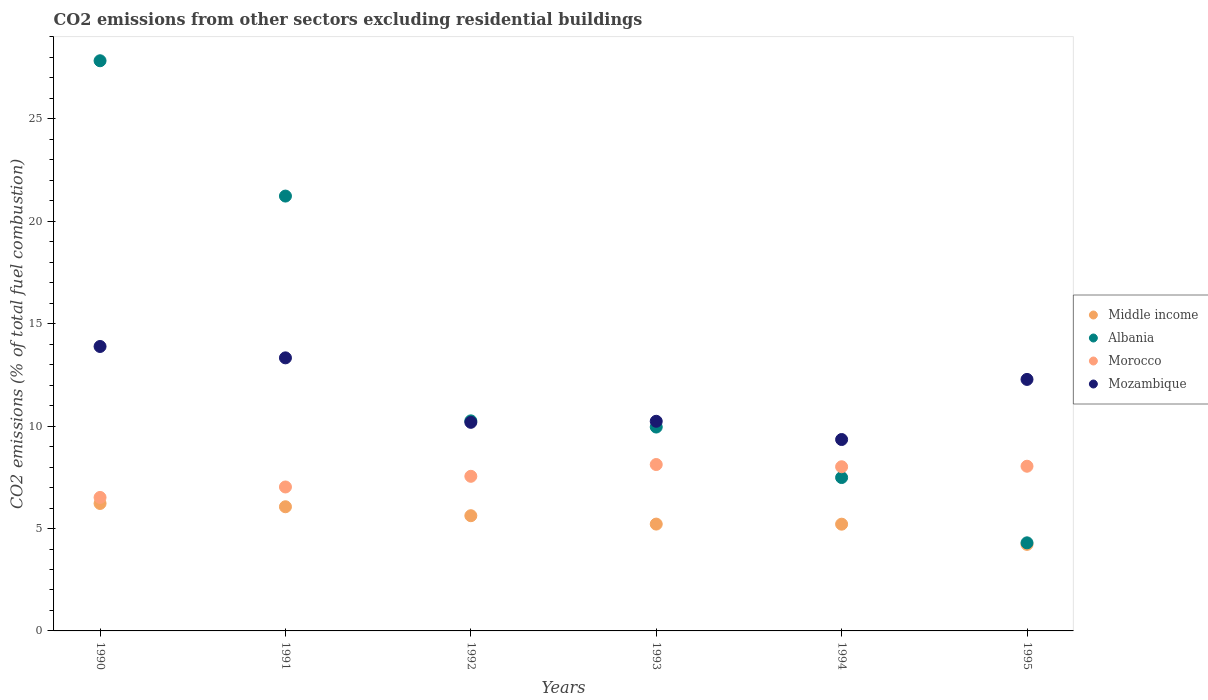How many different coloured dotlines are there?
Ensure brevity in your answer.  4. What is the total CO2 emitted in Morocco in 1990?
Offer a very short reply. 6.52. Across all years, what is the maximum total CO2 emitted in Albania?
Make the answer very short. 27.84. Across all years, what is the minimum total CO2 emitted in Mozambique?
Offer a terse response. 9.35. In which year was the total CO2 emitted in Mozambique minimum?
Provide a short and direct response. 1994. What is the total total CO2 emitted in Middle income in the graph?
Ensure brevity in your answer.  32.56. What is the difference between the total CO2 emitted in Mozambique in 1992 and that in 1995?
Provide a short and direct response. -2.1. What is the difference between the total CO2 emitted in Morocco in 1993 and the total CO2 emitted in Middle income in 1992?
Provide a short and direct response. 2.5. What is the average total CO2 emitted in Albania per year?
Offer a very short reply. 13.51. In the year 1992, what is the difference between the total CO2 emitted in Morocco and total CO2 emitted in Albania?
Provide a short and direct response. -2.71. What is the ratio of the total CO2 emitted in Middle income in 1994 to that in 1995?
Offer a very short reply. 1.23. What is the difference between the highest and the second highest total CO2 emitted in Morocco?
Offer a very short reply. 0.08. What is the difference between the highest and the lowest total CO2 emitted in Middle income?
Provide a succinct answer. 2. Is it the case that in every year, the sum of the total CO2 emitted in Albania and total CO2 emitted in Middle income  is greater than the sum of total CO2 emitted in Morocco and total CO2 emitted in Mozambique?
Keep it short and to the point. No. Is the total CO2 emitted in Albania strictly greater than the total CO2 emitted in Middle income over the years?
Offer a very short reply. Yes. How many dotlines are there?
Offer a very short reply. 4. What is the difference between two consecutive major ticks on the Y-axis?
Offer a very short reply. 5. Are the values on the major ticks of Y-axis written in scientific E-notation?
Your answer should be very brief. No. Does the graph contain any zero values?
Offer a terse response. No. Does the graph contain grids?
Provide a succinct answer. No. How many legend labels are there?
Provide a succinct answer. 4. What is the title of the graph?
Provide a succinct answer. CO2 emissions from other sectors excluding residential buildings. What is the label or title of the X-axis?
Offer a very short reply. Years. What is the label or title of the Y-axis?
Your response must be concise. CO2 emissions (% of total fuel combustion). What is the CO2 emissions (% of total fuel combustion) of Middle income in 1990?
Offer a very short reply. 6.22. What is the CO2 emissions (% of total fuel combustion) in Albania in 1990?
Offer a terse response. 27.84. What is the CO2 emissions (% of total fuel combustion) in Morocco in 1990?
Make the answer very short. 6.52. What is the CO2 emissions (% of total fuel combustion) of Mozambique in 1990?
Provide a short and direct response. 13.89. What is the CO2 emissions (% of total fuel combustion) in Middle income in 1991?
Provide a succinct answer. 6.06. What is the CO2 emissions (% of total fuel combustion) in Albania in 1991?
Provide a succinct answer. 21.23. What is the CO2 emissions (% of total fuel combustion) in Morocco in 1991?
Offer a terse response. 7.03. What is the CO2 emissions (% of total fuel combustion) in Mozambique in 1991?
Make the answer very short. 13.33. What is the CO2 emissions (% of total fuel combustion) of Middle income in 1992?
Provide a succinct answer. 5.63. What is the CO2 emissions (% of total fuel combustion) in Albania in 1992?
Offer a very short reply. 10.26. What is the CO2 emissions (% of total fuel combustion) of Morocco in 1992?
Your answer should be compact. 7.55. What is the CO2 emissions (% of total fuel combustion) of Mozambique in 1992?
Keep it short and to the point. 10.19. What is the CO2 emissions (% of total fuel combustion) of Middle income in 1993?
Offer a terse response. 5.22. What is the CO2 emissions (% of total fuel combustion) of Albania in 1993?
Give a very brief answer. 9.95. What is the CO2 emissions (% of total fuel combustion) of Morocco in 1993?
Keep it short and to the point. 8.12. What is the CO2 emissions (% of total fuel combustion) in Mozambique in 1993?
Your response must be concise. 10.24. What is the CO2 emissions (% of total fuel combustion) of Middle income in 1994?
Ensure brevity in your answer.  5.21. What is the CO2 emissions (% of total fuel combustion) of Albania in 1994?
Your response must be concise. 7.49. What is the CO2 emissions (% of total fuel combustion) of Morocco in 1994?
Make the answer very short. 8.02. What is the CO2 emissions (% of total fuel combustion) of Mozambique in 1994?
Make the answer very short. 9.35. What is the CO2 emissions (% of total fuel combustion) of Middle income in 1995?
Your response must be concise. 4.23. What is the CO2 emissions (% of total fuel combustion) in Albania in 1995?
Make the answer very short. 4.3. What is the CO2 emissions (% of total fuel combustion) in Morocco in 1995?
Give a very brief answer. 8.04. What is the CO2 emissions (% of total fuel combustion) of Mozambique in 1995?
Your answer should be very brief. 12.28. Across all years, what is the maximum CO2 emissions (% of total fuel combustion) of Middle income?
Offer a terse response. 6.22. Across all years, what is the maximum CO2 emissions (% of total fuel combustion) of Albania?
Ensure brevity in your answer.  27.84. Across all years, what is the maximum CO2 emissions (% of total fuel combustion) of Morocco?
Offer a very short reply. 8.12. Across all years, what is the maximum CO2 emissions (% of total fuel combustion) in Mozambique?
Keep it short and to the point. 13.89. Across all years, what is the minimum CO2 emissions (% of total fuel combustion) in Middle income?
Ensure brevity in your answer.  4.23. Across all years, what is the minimum CO2 emissions (% of total fuel combustion) of Albania?
Ensure brevity in your answer.  4.3. Across all years, what is the minimum CO2 emissions (% of total fuel combustion) in Morocco?
Provide a succinct answer. 6.52. Across all years, what is the minimum CO2 emissions (% of total fuel combustion) of Mozambique?
Offer a terse response. 9.35. What is the total CO2 emissions (% of total fuel combustion) in Middle income in the graph?
Provide a short and direct response. 32.56. What is the total CO2 emissions (% of total fuel combustion) of Albania in the graph?
Give a very brief answer. 81.07. What is the total CO2 emissions (% of total fuel combustion) in Morocco in the graph?
Offer a very short reply. 45.28. What is the total CO2 emissions (% of total fuel combustion) in Mozambique in the graph?
Make the answer very short. 69.27. What is the difference between the CO2 emissions (% of total fuel combustion) of Middle income in 1990 and that in 1991?
Your response must be concise. 0.16. What is the difference between the CO2 emissions (% of total fuel combustion) of Albania in 1990 and that in 1991?
Your answer should be compact. 6.61. What is the difference between the CO2 emissions (% of total fuel combustion) in Morocco in 1990 and that in 1991?
Your response must be concise. -0.51. What is the difference between the CO2 emissions (% of total fuel combustion) of Mozambique in 1990 and that in 1991?
Keep it short and to the point. 0.56. What is the difference between the CO2 emissions (% of total fuel combustion) of Middle income in 1990 and that in 1992?
Provide a short and direct response. 0.6. What is the difference between the CO2 emissions (% of total fuel combustion) of Albania in 1990 and that in 1992?
Ensure brevity in your answer.  17.58. What is the difference between the CO2 emissions (% of total fuel combustion) in Morocco in 1990 and that in 1992?
Provide a succinct answer. -1.03. What is the difference between the CO2 emissions (% of total fuel combustion) of Mozambique in 1990 and that in 1992?
Provide a succinct answer. 3.7. What is the difference between the CO2 emissions (% of total fuel combustion) in Middle income in 1990 and that in 1993?
Make the answer very short. 1.01. What is the difference between the CO2 emissions (% of total fuel combustion) in Albania in 1990 and that in 1993?
Offer a very short reply. 17.89. What is the difference between the CO2 emissions (% of total fuel combustion) of Morocco in 1990 and that in 1993?
Offer a terse response. -1.61. What is the difference between the CO2 emissions (% of total fuel combustion) of Mozambique in 1990 and that in 1993?
Your answer should be very brief. 3.65. What is the difference between the CO2 emissions (% of total fuel combustion) of Albania in 1990 and that in 1994?
Make the answer very short. 20.35. What is the difference between the CO2 emissions (% of total fuel combustion) of Morocco in 1990 and that in 1994?
Your answer should be compact. -1.5. What is the difference between the CO2 emissions (% of total fuel combustion) in Mozambique in 1990 and that in 1994?
Make the answer very short. 4.54. What is the difference between the CO2 emissions (% of total fuel combustion) of Middle income in 1990 and that in 1995?
Your answer should be very brief. 2. What is the difference between the CO2 emissions (% of total fuel combustion) of Albania in 1990 and that in 1995?
Offer a very short reply. 23.54. What is the difference between the CO2 emissions (% of total fuel combustion) in Morocco in 1990 and that in 1995?
Offer a very short reply. -1.52. What is the difference between the CO2 emissions (% of total fuel combustion) of Mozambique in 1990 and that in 1995?
Give a very brief answer. 1.61. What is the difference between the CO2 emissions (% of total fuel combustion) in Middle income in 1991 and that in 1992?
Give a very brief answer. 0.44. What is the difference between the CO2 emissions (% of total fuel combustion) of Albania in 1991 and that in 1992?
Provide a succinct answer. 10.98. What is the difference between the CO2 emissions (% of total fuel combustion) of Morocco in 1991 and that in 1992?
Give a very brief answer. -0.52. What is the difference between the CO2 emissions (% of total fuel combustion) of Mozambique in 1991 and that in 1992?
Make the answer very short. 3.15. What is the difference between the CO2 emissions (% of total fuel combustion) in Middle income in 1991 and that in 1993?
Provide a succinct answer. 0.85. What is the difference between the CO2 emissions (% of total fuel combustion) of Albania in 1991 and that in 1993?
Your response must be concise. 11.28. What is the difference between the CO2 emissions (% of total fuel combustion) of Morocco in 1991 and that in 1993?
Make the answer very short. -1.1. What is the difference between the CO2 emissions (% of total fuel combustion) of Mozambique in 1991 and that in 1993?
Give a very brief answer. 3.1. What is the difference between the CO2 emissions (% of total fuel combustion) in Middle income in 1991 and that in 1994?
Your response must be concise. 0.85. What is the difference between the CO2 emissions (% of total fuel combustion) in Albania in 1991 and that in 1994?
Offer a terse response. 13.74. What is the difference between the CO2 emissions (% of total fuel combustion) in Morocco in 1991 and that in 1994?
Your response must be concise. -0.99. What is the difference between the CO2 emissions (% of total fuel combustion) of Mozambique in 1991 and that in 1994?
Ensure brevity in your answer.  3.99. What is the difference between the CO2 emissions (% of total fuel combustion) of Middle income in 1991 and that in 1995?
Your response must be concise. 1.84. What is the difference between the CO2 emissions (% of total fuel combustion) in Albania in 1991 and that in 1995?
Offer a very short reply. 16.93. What is the difference between the CO2 emissions (% of total fuel combustion) of Morocco in 1991 and that in 1995?
Your response must be concise. -1.01. What is the difference between the CO2 emissions (% of total fuel combustion) of Mozambique in 1991 and that in 1995?
Keep it short and to the point. 1.05. What is the difference between the CO2 emissions (% of total fuel combustion) of Middle income in 1992 and that in 1993?
Make the answer very short. 0.41. What is the difference between the CO2 emissions (% of total fuel combustion) in Albania in 1992 and that in 1993?
Make the answer very short. 0.3. What is the difference between the CO2 emissions (% of total fuel combustion) of Morocco in 1992 and that in 1993?
Make the answer very short. -0.57. What is the difference between the CO2 emissions (% of total fuel combustion) in Mozambique in 1992 and that in 1993?
Make the answer very short. -0.05. What is the difference between the CO2 emissions (% of total fuel combustion) in Middle income in 1992 and that in 1994?
Provide a succinct answer. 0.41. What is the difference between the CO2 emissions (% of total fuel combustion) in Albania in 1992 and that in 1994?
Keep it short and to the point. 2.77. What is the difference between the CO2 emissions (% of total fuel combustion) in Morocco in 1992 and that in 1994?
Provide a short and direct response. -0.47. What is the difference between the CO2 emissions (% of total fuel combustion) of Mozambique in 1992 and that in 1994?
Ensure brevity in your answer.  0.84. What is the difference between the CO2 emissions (% of total fuel combustion) of Middle income in 1992 and that in 1995?
Offer a very short reply. 1.4. What is the difference between the CO2 emissions (% of total fuel combustion) in Albania in 1992 and that in 1995?
Give a very brief answer. 5.96. What is the difference between the CO2 emissions (% of total fuel combustion) of Morocco in 1992 and that in 1995?
Keep it short and to the point. -0.49. What is the difference between the CO2 emissions (% of total fuel combustion) of Mozambique in 1992 and that in 1995?
Keep it short and to the point. -2.1. What is the difference between the CO2 emissions (% of total fuel combustion) of Middle income in 1993 and that in 1994?
Offer a very short reply. 0. What is the difference between the CO2 emissions (% of total fuel combustion) of Albania in 1993 and that in 1994?
Make the answer very short. 2.47. What is the difference between the CO2 emissions (% of total fuel combustion) of Morocco in 1993 and that in 1994?
Your answer should be compact. 0.11. What is the difference between the CO2 emissions (% of total fuel combustion) in Mozambique in 1993 and that in 1994?
Keep it short and to the point. 0.89. What is the difference between the CO2 emissions (% of total fuel combustion) in Middle income in 1993 and that in 1995?
Give a very brief answer. 0.99. What is the difference between the CO2 emissions (% of total fuel combustion) of Albania in 1993 and that in 1995?
Your answer should be compact. 5.65. What is the difference between the CO2 emissions (% of total fuel combustion) of Morocco in 1993 and that in 1995?
Your answer should be compact. 0.08. What is the difference between the CO2 emissions (% of total fuel combustion) of Mozambique in 1993 and that in 1995?
Offer a terse response. -2.04. What is the difference between the CO2 emissions (% of total fuel combustion) in Middle income in 1994 and that in 1995?
Provide a succinct answer. 0.99. What is the difference between the CO2 emissions (% of total fuel combustion) in Albania in 1994 and that in 1995?
Keep it short and to the point. 3.19. What is the difference between the CO2 emissions (% of total fuel combustion) in Morocco in 1994 and that in 1995?
Give a very brief answer. -0.03. What is the difference between the CO2 emissions (% of total fuel combustion) in Mozambique in 1994 and that in 1995?
Your answer should be very brief. -2.93. What is the difference between the CO2 emissions (% of total fuel combustion) of Middle income in 1990 and the CO2 emissions (% of total fuel combustion) of Albania in 1991?
Keep it short and to the point. -15.01. What is the difference between the CO2 emissions (% of total fuel combustion) of Middle income in 1990 and the CO2 emissions (% of total fuel combustion) of Morocco in 1991?
Offer a very short reply. -0.81. What is the difference between the CO2 emissions (% of total fuel combustion) in Middle income in 1990 and the CO2 emissions (% of total fuel combustion) in Mozambique in 1991?
Your answer should be compact. -7.11. What is the difference between the CO2 emissions (% of total fuel combustion) of Albania in 1990 and the CO2 emissions (% of total fuel combustion) of Morocco in 1991?
Your answer should be compact. 20.81. What is the difference between the CO2 emissions (% of total fuel combustion) of Albania in 1990 and the CO2 emissions (% of total fuel combustion) of Mozambique in 1991?
Your answer should be compact. 14.51. What is the difference between the CO2 emissions (% of total fuel combustion) in Morocco in 1990 and the CO2 emissions (% of total fuel combustion) in Mozambique in 1991?
Provide a short and direct response. -6.82. What is the difference between the CO2 emissions (% of total fuel combustion) in Middle income in 1990 and the CO2 emissions (% of total fuel combustion) in Albania in 1992?
Ensure brevity in your answer.  -4.03. What is the difference between the CO2 emissions (% of total fuel combustion) of Middle income in 1990 and the CO2 emissions (% of total fuel combustion) of Morocco in 1992?
Make the answer very short. -1.33. What is the difference between the CO2 emissions (% of total fuel combustion) in Middle income in 1990 and the CO2 emissions (% of total fuel combustion) in Mozambique in 1992?
Your response must be concise. -3.96. What is the difference between the CO2 emissions (% of total fuel combustion) in Albania in 1990 and the CO2 emissions (% of total fuel combustion) in Morocco in 1992?
Make the answer very short. 20.29. What is the difference between the CO2 emissions (% of total fuel combustion) of Albania in 1990 and the CO2 emissions (% of total fuel combustion) of Mozambique in 1992?
Provide a succinct answer. 17.65. What is the difference between the CO2 emissions (% of total fuel combustion) of Morocco in 1990 and the CO2 emissions (% of total fuel combustion) of Mozambique in 1992?
Provide a succinct answer. -3.67. What is the difference between the CO2 emissions (% of total fuel combustion) of Middle income in 1990 and the CO2 emissions (% of total fuel combustion) of Albania in 1993?
Your response must be concise. -3.73. What is the difference between the CO2 emissions (% of total fuel combustion) in Middle income in 1990 and the CO2 emissions (% of total fuel combustion) in Morocco in 1993?
Provide a short and direct response. -1.9. What is the difference between the CO2 emissions (% of total fuel combustion) of Middle income in 1990 and the CO2 emissions (% of total fuel combustion) of Mozambique in 1993?
Offer a very short reply. -4.01. What is the difference between the CO2 emissions (% of total fuel combustion) of Albania in 1990 and the CO2 emissions (% of total fuel combustion) of Morocco in 1993?
Provide a succinct answer. 19.72. What is the difference between the CO2 emissions (% of total fuel combustion) in Albania in 1990 and the CO2 emissions (% of total fuel combustion) in Mozambique in 1993?
Keep it short and to the point. 17.6. What is the difference between the CO2 emissions (% of total fuel combustion) of Morocco in 1990 and the CO2 emissions (% of total fuel combustion) of Mozambique in 1993?
Your answer should be very brief. -3.72. What is the difference between the CO2 emissions (% of total fuel combustion) in Middle income in 1990 and the CO2 emissions (% of total fuel combustion) in Albania in 1994?
Your response must be concise. -1.27. What is the difference between the CO2 emissions (% of total fuel combustion) in Middle income in 1990 and the CO2 emissions (% of total fuel combustion) in Morocco in 1994?
Offer a very short reply. -1.79. What is the difference between the CO2 emissions (% of total fuel combustion) of Middle income in 1990 and the CO2 emissions (% of total fuel combustion) of Mozambique in 1994?
Your response must be concise. -3.12. What is the difference between the CO2 emissions (% of total fuel combustion) in Albania in 1990 and the CO2 emissions (% of total fuel combustion) in Morocco in 1994?
Offer a terse response. 19.82. What is the difference between the CO2 emissions (% of total fuel combustion) in Albania in 1990 and the CO2 emissions (% of total fuel combustion) in Mozambique in 1994?
Offer a very short reply. 18.49. What is the difference between the CO2 emissions (% of total fuel combustion) of Morocco in 1990 and the CO2 emissions (% of total fuel combustion) of Mozambique in 1994?
Your response must be concise. -2.83. What is the difference between the CO2 emissions (% of total fuel combustion) of Middle income in 1990 and the CO2 emissions (% of total fuel combustion) of Albania in 1995?
Keep it short and to the point. 1.92. What is the difference between the CO2 emissions (% of total fuel combustion) of Middle income in 1990 and the CO2 emissions (% of total fuel combustion) of Morocco in 1995?
Provide a succinct answer. -1.82. What is the difference between the CO2 emissions (% of total fuel combustion) of Middle income in 1990 and the CO2 emissions (% of total fuel combustion) of Mozambique in 1995?
Your answer should be very brief. -6.06. What is the difference between the CO2 emissions (% of total fuel combustion) in Albania in 1990 and the CO2 emissions (% of total fuel combustion) in Morocco in 1995?
Ensure brevity in your answer.  19.8. What is the difference between the CO2 emissions (% of total fuel combustion) in Albania in 1990 and the CO2 emissions (% of total fuel combustion) in Mozambique in 1995?
Provide a short and direct response. 15.56. What is the difference between the CO2 emissions (% of total fuel combustion) of Morocco in 1990 and the CO2 emissions (% of total fuel combustion) of Mozambique in 1995?
Offer a terse response. -5.76. What is the difference between the CO2 emissions (% of total fuel combustion) of Middle income in 1991 and the CO2 emissions (% of total fuel combustion) of Albania in 1992?
Your answer should be compact. -4.19. What is the difference between the CO2 emissions (% of total fuel combustion) of Middle income in 1991 and the CO2 emissions (% of total fuel combustion) of Morocco in 1992?
Make the answer very short. -1.49. What is the difference between the CO2 emissions (% of total fuel combustion) in Middle income in 1991 and the CO2 emissions (% of total fuel combustion) in Mozambique in 1992?
Your response must be concise. -4.12. What is the difference between the CO2 emissions (% of total fuel combustion) in Albania in 1991 and the CO2 emissions (% of total fuel combustion) in Morocco in 1992?
Your response must be concise. 13.68. What is the difference between the CO2 emissions (% of total fuel combustion) in Albania in 1991 and the CO2 emissions (% of total fuel combustion) in Mozambique in 1992?
Give a very brief answer. 11.05. What is the difference between the CO2 emissions (% of total fuel combustion) in Morocco in 1991 and the CO2 emissions (% of total fuel combustion) in Mozambique in 1992?
Offer a very short reply. -3.16. What is the difference between the CO2 emissions (% of total fuel combustion) of Middle income in 1991 and the CO2 emissions (% of total fuel combustion) of Albania in 1993?
Offer a terse response. -3.89. What is the difference between the CO2 emissions (% of total fuel combustion) of Middle income in 1991 and the CO2 emissions (% of total fuel combustion) of Morocco in 1993?
Provide a succinct answer. -2.06. What is the difference between the CO2 emissions (% of total fuel combustion) of Middle income in 1991 and the CO2 emissions (% of total fuel combustion) of Mozambique in 1993?
Keep it short and to the point. -4.17. What is the difference between the CO2 emissions (% of total fuel combustion) in Albania in 1991 and the CO2 emissions (% of total fuel combustion) in Morocco in 1993?
Keep it short and to the point. 13.11. What is the difference between the CO2 emissions (% of total fuel combustion) of Albania in 1991 and the CO2 emissions (% of total fuel combustion) of Mozambique in 1993?
Provide a short and direct response. 11. What is the difference between the CO2 emissions (% of total fuel combustion) of Morocco in 1991 and the CO2 emissions (% of total fuel combustion) of Mozambique in 1993?
Ensure brevity in your answer.  -3.21. What is the difference between the CO2 emissions (% of total fuel combustion) in Middle income in 1991 and the CO2 emissions (% of total fuel combustion) in Albania in 1994?
Offer a very short reply. -1.43. What is the difference between the CO2 emissions (% of total fuel combustion) in Middle income in 1991 and the CO2 emissions (% of total fuel combustion) in Morocco in 1994?
Ensure brevity in your answer.  -1.95. What is the difference between the CO2 emissions (% of total fuel combustion) of Middle income in 1991 and the CO2 emissions (% of total fuel combustion) of Mozambique in 1994?
Offer a terse response. -3.28. What is the difference between the CO2 emissions (% of total fuel combustion) of Albania in 1991 and the CO2 emissions (% of total fuel combustion) of Morocco in 1994?
Keep it short and to the point. 13.22. What is the difference between the CO2 emissions (% of total fuel combustion) of Albania in 1991 and the CO2 emissions (% of total fuel combustion) of Mozambique in 1994?
Give a very brief answer. 11.89. What is the difference between the CO2 emissions (% of total fuel combustion) in Morocco in 1991 and the CO2 emissions (% of total fuel combustion) in Mozambique in 1994?
Provide a succinct answer. -2.32. What is the difference between the CO2 emissions (% of total fuel combustion) in Middle income in 1991 and the CO2 emissions (% of total fuel combustion) in Albania in 1995?
Offer a terse response. 1.76. What is the difference between the CO2 emissions (% of total fuel combustion) in Middle income in 1991 and the CO2 emissions (% of total fuel combustion) in Morocco in 1995?
Your answer should be compact. -1.98. What is the difference between the CO2 emissions (% of total fuel combustion) in Middle income in 1991 and the CO2 emissions (% of total fuel combustion) in Mozambique in 1995?
Provide a short and direct response. -6.22. What is the difference between the CO2 emissions (% of total fuel combustion) in Albania in 1991 and the CO2 emissions (% of total fuel combustion) in Morocco in 1995?
Ensure brevity in your answer.  13.19. What is the difference between the CO2 emissions (% of total fuel combustion) of Albania in 1991 and the CO2 emissions (% of total fuel combustion) of Mozambique in 1995?
Give a very brief answer. 8.95. What is the difference between the CO2 emissions (% of total fuel combustion) in Morocco in 1991 and the CO2 emissions (% of total fuel combustion) in Mozambique in 1995?
Make the answer very short. -5.25. What is the difference between the CO2 emissions (% of total fuel combustion) in Middle income in 1992 and the CO2 emissions (% of total fuel combustion) in Albania in 1993?
Offer a terse response. -4.33. What is the difference between the CO2 emissions (% of total fuel combustion) in Middle income in 1992 and the CO2 emissions (% of total fuel combustion) in Morocco in 1993?
Ensure brevity in your answer.  -2.5. What is the difference between the CO2 emissions (% of total fuel combustion) in Middle income in 1992 and the CO2 emissions (% of total fuel combustion) in Mozambique in 1993?
Offer a very short reply. -4.61. What is the difference between the CO2 emissions (% of total fuel combustion) of Albania in 1992 and the CO2 emissions (% of total fuel combustion) of Morocco in 1993?
Give a very brief answer. 2.13. What is the difference between the CO2 emissions (% of total fuel combustion) in Albania in 1992 and the CO2 emissions (% of total fuel combustion) in Mozambique in 1993?
Offer a very short reply. 0.02. What is the difference between the CO2 emissions (% of total fuel combustion) in Morocco in 1992 and the CO2 emissions (% of total fuel combustion) in Mozambique in 1993?
Ensure brevity in your answer.  -2.69. What is the difference between the CO2 emissions (% of total fuel combustion) of Middle income in 1992 and the CO2 emissions (% of total fuel combustion) of Albania in 1994?
Provide a short and direct response. -1.86. What is the difference between the CO2 emissions (% of total fuel combustion) in Middle income in 1992 and the CO2 emissions (% of total fuel combustion) in Morocco in 1994?
Make the answer very short. -2.39. What is the difference between the CO2 emissions (% of total fuel combustion) in Middle income in 1992 and the CO2 emissions (% of total fuel combustion) in Mozambique in 1994?
Your answer should be very brief. -3.72. What is the difference between the CO2 emissions (% of total fuel combustion) of Albania in 1992 and the CO2 emissions (% of total fuel combustion) of Morocco in 1994?
Your answer should be very brief. 2.24. What is the difference between the CO2 emissions (% of total fuel combustion) in Albania in 1992 and the CO2 emissions (% of total fuel combustion) in Mozambique in 1994?
Your answer should be compact. 0.91. What is the difference between the CO2 emissions (% of total fuel combustion) in Morocco in 1992 and the CO2 emissions (% of total fuel combustion) in Mozambique in 1994?
Your answer should be very brief. -1.8. What is the difference between the CO2 emissions (% of total fuel combustion) of Middle income in 1992 and the CO2 emissions (% of total fuel combustion) of Albania in 1995?
Keep it short and to the point. 1.32. What is the difference between the CO2 emissions (% of total fuel combustion) of Middle income in 1992 and the CO2 emissions (% of total fuel combustion) of Morocco in 1995?
Your answer should be compact. -2.42. What is the difference between the CO2 emissions (% of total fuel combustion) of Middle income in 1992 and the CO2 emissions (% of total fuel combustion) of Mozambique in 1995?
Offer a terse response. -6.66. What is the difference between the CO2 emissions (% of total fuel combustion) in Albania in 1992 and the CO2 emissions (% of total fuel combustion) in Morocco in 1995?
Provide a short and direct response. 2.21. What is the difference between the CO2 emissions (% of total fuel combustion) in Albania in 1992 and the CO2 emissions (% of total fuel combustion) in Mozambique in 1995?
Offer a very short reply. -2.02. What is the difference between the CO2 emissions (% of total fuel combustion) of Morocco in 1992 and the CO2 emissions (% of total fuel combustion) of Mozambique in 1995?
Keep it short and to the point. -4.73. What is the difference between the CO2 emissions (% of total fuel combustion) in Middle income in 1993 and the CO2 emissions (% of total fuel combustion) in Albania in 1994?
Make the answer very short. -2.27. What is the difference between the CO2 emissions (% of total fuel combustion) in Middle income in 1993 and the CO2 emissions (% of total fuel combustion) in Morocco in 1994?
Offer a very short reply. -2.8. What is the difference between the CO2 emissions (% of total fuel combustion) of Middle income in 1993 and the CO2 emissions (% of total fuel combustion) of Mozambique in 1994?
Give a very brief answer. -4.13. What is the difference between the CO2 emissions (% of total fuel combustion) in Albania in 1993 and the CO2 emissions (% of total fuel combustion) in Morocco in 1994?
Offer a very short reply. 1.94. What is the difference between the CO2 emissions (% of total fuel combustion) in Albania in 1993 and the CO2 emissions (% of total fuel combustion) in Mozambique in 1994?
Your answer should be very brief. 0.61. What is the difference between the CO2 emissions (% of total fuel combustion) of Morocco in 1993 and the CO2 emissions (% of total fuel combustion) of Mozambique in 1994?
Ensure brevity in your answer.  -1.22. What is the difference between the CO2 emissions (% of total fuel combustion) of Middle income in 1993 and the CO2 emissions (% of total fuel combustion) of Albania in 1995?
Your response must be concise. 0.92. What is the difference between the CO2 emissions (% of total fuel combustion) of Middle income in 1993 and the CO2 emissions (% of total fuel combustion) of Morocco in 1995?
Your answer should be very brief. -2.83. What is the difference between the CO2 emissions (% of total fuel combustion) of Middle income in 1993 and the CO2 emissions (% of total fuel combustion) of Mozambique in 1995?
Provide a succinct answer. -7.06. What is the difference between the CO2 emissions (% of total fuel combustion) of Albania in 1993 and the CO2 emissions (% of total fuel combustion) of Morocco in 1995?
Make the answer very short. 1.91. What is the difference between the CO2 emissions (% of total fuel combustion) in Albania in 1993 and the CO2 emissions (% of total fuel combustion) in Mozambique in 1995?
Give a very brief answer. -2.33. What is the difference between the CO2 emissions (% of total fuel combustion) of Morocco in 1993 and the CO2 emissions (% of total fuel combustion) of Mozambique in 1995?
Ensure brevity in your answer.  -4.16. What is the difference between the CO2 emissions (% of total fuel combustion) in Middle income in 1994 and the CO2 emissions (% of total fuel combustion) in Albania in 1995?
Provide a short and direct response. 0.91. What is the difference between the CO2 emissions (% of total fuel combustion) in Middle income in 1994 and the CO2 emissions (% of total fuel combustion) in Morocco in 1995?
Keep it short and to the point. -2.83. What is the difference between the CO2 emissions (% of total fuel combustion) of Middle income in 1994 and the CO2 emissions (% of total fuel combustion) of Mozambique in 1995?
Make the answer very short. -7.07. What is the difference between the CO2 emissions (% of total fuel combustion) of Albania in 1994 and the CO2 emissions (% of total fuel combustion) of Morocco in 1995?
Make the answer very short. -0.55. What is the difference between the CO2 emissions (% of total fuel combustion) of Albania in 1994 and the CO2 emissions (% of total fuel combustion) of Mozambique in 1995?
Provide a short and direct response. -4.79. What is the difference between the CO2 emissions (% of total fuel combustion) of Morocco in 1994 and the CO2 emissions (% of total fuel combustion) of Mozambique in 1995?
Provide a succinct answer. -4.26. What is the average CO2 emissions (% of total fuel combustion) of Middle income per year?
Your answer should be very brief. 5.43. What is the average CO2 emissions (% of total fuel combustion) in Albania per year?
Give a very brief answer. 13.51. What is the average CO2 emissions (% of total fuel combustion) of Morocco per year?
Keep it short and to the point. 7.55. What is the average CO2 emissions (% of total fuel combustion) of Mozambique per year?
Your answer should be compact. 11.54. In the year 1990, what is the difference between the CO2 emissions (% of total fuel combustion) of Middle income and CO2 emissions (% of total fuel combustion) of Albania?
Give a very brief answer. -21.62. In the year 1990, what is the difference between the CO2 emissions (% of total fuel combustion) of Middle income and CO2 emissions (% of total fuel combustion) of Morocco?
Your answer should be very brief. -0.29. In the year 1990, what is the difference between the CO2 emissions (% of total fuel combustion) of Middle income and CO2 emissions (% of total fuel combustion) of Mozambique?
Your response must be concise. -7.67. In the year 1990, what is the difference between the CO2 emissions (% of total fuel combustion) of Albania and CO2 emissions (% of total fuel combustion) of Morocco?
Make the answer very short. 21.32. In the year 1990, what is the difference between the CO2 emissions (% of total fuel combustion) in Albania and CO2 emissions (% of total fuel combustion) in Mozambique?
Make the answer very short. 13.95. In the year 1990, what is the difference between the CO2 emissions (% of total fuel combustion) of Morocco and CO2 emissions (% of total fuel combustion) of Mozambique?
Your answer should be very brief. -7.37. In the year 1991, what is the difference between the CO2 emissions (% of total fuel combustion) of Middle income and CO2 emissions (% of total fuel combustion) of Albania?
Give a very brief answer. -15.17. In the year 1991, what is the difference between the CO2 emissions (% of total fuel combustion) of Middle income and CO2 emissions (% of total fuel combustion) of Morocco?
Provide a succinct answer. -0.97. In the year 1991, what is the difference between the CO2 emissions (% of total fuel combustion) in Middle income and CO2 emissions (% of total fuel combustion) in Mozambique?
Offer a terse response. -7.27. In the year 1991, what is the difference between the CO2 emissions (% of total fuel combustion) in Albania and CO2 emissions (% of total fuel combustion) in Morocco?
Provide a succinct answer. 14.2. In the year 1991, what is the difference between the CO2 emissions (% of total fuel combustion) of Albania and CO2 emissions (% of total fuel combustion) of Mozambique?
Keep it short and to the point. 7.9. In the year 1991, what is the difference between the CO2 emissions (% of total fuel combustion) of Morocco and CO2 emissions (% of total fuel combustion) of Mozambique?
Provide a short and direct response. -6.3. In the year 1992, what is the difference between the CO2 emissions (% of total fuel combustion) in Middle income and CO2 emissions (% of total fuel combustion) in Albania?
Your answer should be compact. -4.63. In the year 1992, what is the difference between the CO2 emissions (% of total fuel combustion) in Middle income and CO2 emissions (% of total fuel combustion) in Morocco?
Your answer should be very brief. -1.92. In the year 1992, what is the difference between the CO2 emissions (% of total fuel combustion) of Middle income and CO2 emissions (% of total fuel combustion) of Mozambique?
Provide a succinct answer. -4.56. In the year 1992, what is the difference between the CO2 emissions (% of total fuel combustion) of Albania and CO2 emissions (% of total fuel combustion) of Morocco?
Keep it short and to the point. 2.71. In the year 1992, what is the difference between the CO2 emissions (% of total fuel combustion) in Albania and CO2 emissions (% of total fuel combustion) in Mozambique?
Offer a terse response. 0.07. In the year 1992, what is the difference between the CO2 emissions (% of total fuel combustion) of Morocco and CO2 emissions (% of total fuel combustion) of Mozambique?
Keep it short and to the point. -2.64. In the year 1993, what is the difference between the CO2 emissions (% of total fuel combustion) in Middle income and CO2 emissions (% of total fuel combustion) in Albania?
Provide a short and direct response. -4.74. In the year 1993, what is the difference between the CO2 emissions (% of total fuel combustion) in Middle income and CO2 emissions (% of total fuel combustion) in Morocco?
Offer a terse response. -2.91. In the year 1993, what is the difference between the CO2 emissions (% of total fuel combustion) in Middle income and CO2 emissions (% of total fuel combustion) in Mozambique?
Your answer should be very brief. -5.02. In the year 1993, what is the difference between the CO2 emissions (% of total fuel combustion) in Albania and CO2 emissions (% of total fuel combustion) in Morocco?
Keep it short and to the point. 1.83. In the year 1993, what is the difference between the CO2 emissions (% of total fuel combustion) of Albania and CO2 emissions (% of total fuel combustion) of Mozambique?
Offer a terse response. -0.28. In the year 1993, what is the difference between the CO2 emissions (% of total fuel combustion) in Morocco and CO2 emissions (% of total fuel combustion) in Mozambique?
Offer a very short reply. -2.11. In the year 1994, what is the difference between the CO2 emissions (% of total fuel combustion) of Middle income and CO2 emissions (% of total fuel combustion) of Albania?
Offer a very short reply. -2.28. In the year 1994, what is the difference between the CO2 emissions (% of total fuel combustion) of Middle income and CO2 emissions (% of total fuel combustion) of Morocco?
Ensure brevity in your answer.  -2.8. In the year 1994, what is the difference between the CO2 emissions (% of total fuel combustion) of Middle income and CO2 emissions (% of total fuel combustion) of Mozambique?
Your answer should be compact. -4.13. In the year 1994, what is the difference between the CO2 emissions (% of total fuel combustion) of Albania and CO2 emissions (% of total fuel combustion) of Morocco?
Give a very brief answer. -0.53. In the year 1994, what is the difference between the CO2 emissions (% of total fuel combustion) of Albania and CO2 emissions (% of total fuel combustion) of Mozambique?
Provide a succinct answer. -1.86. In the year 1994, what is the difference between the CO2 emissions (% of total fuel combustion) in Morocco and CO2 emissions (% of total fuel combustion) in Mozambique?
Provide a succinct answer. -1.33. In the year 1995, what is the difference between the CO2 emissions (% of total fuel combustion) of Middle income and CO2 emissions (% of total fuel combustion) of Albania?
Offer a terse response. -0.08. In the year 1995, what is the difference between the CO2 emissions (% of total fuel combustion) of Middle income and CO2 emissions (% of total fuel combustion) of Morocco?
Give a very brief answer. -3.82. In the year 1995, what is the difference between the CO2 emissions (% of total fuel combustion) in Middle income and CO2 emissions (% of total fuel combustion) in Mozambique?
Give a very brief answer. -8.06. In the year 1995, what is the difference between the CO2 emissions (% of total fuel combustion) of Albania and CO2 emissions (% of total fuel combustion) of Morocco?
Offer a very short reply. -3.74. In the year 1995, what is the difference between the CO2 emissions (% of total fuel combustion) in Albania and CO2 emissions (% of total fuel combustion) in Mozambique?
Offer a terse response. -7.98. In the year 1995, what is the difference between the CO2 emissions (% of total fuel combustion) of Morocco and CO2 emissions (% of total fuel combustion) of Mozambique?
Make the answer very short. -4.24. What is the ratio of the CO2 emissions (% of total fuel combustion) in Middle income in 1990 to that in 1991?
Your response must be concise. 1.03. What is the ratio of the CO2 emissions (% of total fuel combustion) of Albania in 1990 to that in 1991?
Provide a succinct answer. 1.31. What is the ratio of the CO2 emissions (% of total fuel combustion) in Morocco in 1990 to that in 1991?
Give a very brief answer. 0.93. What is the ratio of the CO2 emissions (% of total fuel combustion) in Mozambique in 1990 to that in 1991?
Offer a very short reply. 1.04. What is the ratio of the CO2 emissions (% of total fuel combustion) of Middle income in 1990 to that in 1992?
Your answer should be very brief. 1.11. What is the ratio of the CO2 emissions (% of total fuel combustion) of Albania in 1990 to that in 1992?
Provide a succinct answer. 2.71. What is the ratio of the CO2 emissions (% of total fuel combustion) in Morocco in 1990 to that in 1992?
Your answer should be compact. 0.86. What is the ratio of the CO2 emissions (% of total fuel combustion) in Mozambique in 1990 to that in 1992?
Ensure brevity in your answer.  1.36. What is the ratio of the CO2 emissions (% of total fuel combustion) of Middle income in 1990 to that in 1993?
Ensure brevity in your answer.  1.19. What is the ratio of the CO2 emissions (% of total fuel combustion) in Albania in 1990 to that in 1993?
Offer a terse response. 2.8. What is the ratio of the CO2 emissions (% of total fuel combustion) in Morocco in 1990 to that in 1993?
Ensure brevity in your answer.  0.8. What is the ratio of the CO2 emissions (% of total fuel combustion) in Mozambique in 1990 to that in 1993?
Offer a very short reply. 1.36. What is the ratio of the CO2 emissions (% of total fuel combustion) of Middle income in 1990 to that in 1994?
Your answer should be very brief. 1.19. What is the ratio of the CO2 emissions (% of total fuel combustion) in Albania in 1990 to that in 1994?
Make the answer very short. 3.72. What is the ratio of the CO2 emissions (% of total fuel combustion) of Morocco in 1990 to that in 1994?
Offer a very short reply. 0.81. What is the ratio of the CO2 emissions (% of total fuel combustion) in Mozambique in 1990 to that in 1994?
Ensure brevity in your answer.  1.49. What is the ratio of the CO2 emissions (% of total fuel combustion) of Middle income in 1990 to that in 1995?
Offer a terse response. 1.47. What is the ratio of the CO2 emissions (% of total fuel combustion) in Albania in 1990 to that in 1995?
Provide a short and direct response. 6.47. What is the ratio of the CO2 emissions (% of total fuel combustion) of Morocco in 1990 to that in 1995?
Your response must be concise. 0.81. What is the ratio of the CO2 emissions (% of total fuel combustion) of Mozambique in 1990 to that in 1995?
Provide a succinct answer. 1.13. What is the ratio of the CO2 emissions (% of total fuel combustion) of Middle income in 1991 to that in 1992?
Keep it short and to the point. 1.08. What is the ratio of the CO2 emissions (% of total fuel combustion) of Albania in 1991 to that in 1992?
Your answer should be very brief. 2.07. What is the ratio of the CO2 emissions (% of total fuel combustion) of Mozambique in 1991 to that in 1992?
Your answer should be compact. 1.31. What is the ratio of the CO2 emissions (% of total fuel combustion) of Middle income in 1991 to that in 1993?
Provide a short and direct response. 1.16. What is the ratio of the CO2 emissions (% of total fuel combustion) in Albania in 1991 to that in 1993?
Your answer should be very brief. 2.13. What is the ratio of the CO2 emissions (% of total fuel combustion) in Morocco in 1991 to that in 1993?
Ensure brevity in your answer.  0.87. What is the ratio of the CO2 emissions (% of total fuel combustion) of Mozambique in 1991 to that in 1993?
Ensure brevity in your answer.  1.3. What is the ratio of the CO2 emissions (% of total fuel combustion) in Middle income in 1991 to that in 1994?
Provide a short and direct response. 1.16. What is the ratio of the CO2 emissions (% of total fuel combustion) in Albania in 1991 to that in 1994?
Your response must be concise. 2.84. What is the ratio of the CO2 emissions (% of total fuel combustion) in Morocco in 1991 to that in 1994?
Make the answer very short. 0.88. What is the ratio of the CO2 emissions (% of total fuel combustion) of Mozambique in 1991 to that in 1994?
Your response must be concise. 1.43. What is the ratio of the CO2 emissions (% of total fuel combustion) of Middle income in 1991 to that in 1995?
Keep it short and to the point. 1.43. What is the ratio of the CO2 emissions (% of total fuel combustion) in Albania in 1991 to that in 1995?
Your answer should be very brief. 4.94. What is the ratio of the CO2 emissions (% of total fuel combustion) of Morocco in 1991 to that in 1995?
Ensure brevity in your answer.  0.87. What is the ratio of the CO2 emissions (% of total fuel combustion) of Mozambique in 1991 to that in 1995?
Your answer should be very brief. 1.09. What is the ratio of the CO2 emissions (% of total fuel combustion) in Middle income in 1992 to that in 1993?
Offer a terse response. 1.08. What is the ratio of the CO2 emissions (% of total fuel combustion) of Albania in 1992 to that in 1993?
Keep it short and to the point. 1.03. What is the ratio of the CO2 emissions (% of total fuel combustion) of Morocco in 1992 to that in 1993?
Your response must be concise. 0.93. What is the ratio of the CO2 emissions (% of total fuel combustion) in Middle income in 1992 to that in 1994?
Offer a very short reply. 1.08. What is the ratio of the CO2 emissions (% of total fuel combustion) of Albania in 1992 to that in 1994?
Provide a succinct answer. 1.37. What is the ratio of the CO2 emissions (% of total fuel combustion) of Morocco in 1992 to that in 1994?
Your answer should be very brief. 0.94. What is the ratio of the CO2 emissions (% of total fuel combustion) in Mozambique in 1992 to that in 1994?
Ensure brevity in your answer.  1.09. What is the ratio of the CO2 emissions (% of total fuel combustion) of Middle income in 1992 to that in 1995?
Keep it short and to the point. 1.33. What is the ratio of the CO2 emissions (% of total fuel combustion) of Albania in 1992 to that in 1995?
Your answer should be compact. 2.38. What is the ratio of the CO2 emissions (% of total fuel combustion) of Morocco in 1992 to that in 1995?
Ensure brevity in your answer.  0.94. What is the ratio of the CO2 emissions (% of total fuel combustion) of Mozambique in 1992 to that in 1995?
Keep it short and to the point. 0.83. What is the ratio of the CO2 emissions (% of total fuel combustion) in Albania in 1993 to that in 1994?
Your answer should be compact. 1.33. What is the ratio of the CO2 emissions (% of total fuel combustion) in Morocco in 1993 to that in 1994?
Provide a short and direct response. 1.01. What is the ratio of the CO2 emissions (% of total fuel combustion) of Mozambique in 1993 to that in 1994?
Your response must be concise. 1.1. What is the ratio of the CO2 emissions (% of total fuel combustion) in Middle income in 1993 to that in 1995?
Provide a short and direct response. 1.23. What is the ratio of the CO2 emissions (% of total fuel combustion) in Albania in 1993 to that in 1995?
Your answer should be very brief. 2.31. What is the ratio of the CO2 emissions (% of total fuel combustion) in Morocco in 1993 to that in 1995?
Your answer should be compact. 1.01. What is the ratio of the CO2 emissions (% of total fuel combustion) in Mozambique in 1993 to that in 1995?
Offer a terse response. 0.83. What is the ratio of the CO2 emissions (% of total fuel combustion) of Middle income in 1994 to that in 1995?
Your response must be concise. 1.23. What is the ratio of the CO2 emissions (% of total fuel combustion) of Albania in 1994 to that in 1995?
Provide a succinct answer. 1.74. What is the ratio of the CO2 emissions (% of total fuel combustion) of Mozambique in 1994 to that in 1995?
Make the answer very short. 0.76. What is the difference between the highest and the second highest CO2 emissions (% of total fuel combustion) of Middle income?
Ensure brevity in your answer.  0.16. What is the difference between the highest and the second highest CO2 emissions (% of total fuel combustion) of Albania?
Your response must be concise. 6.61. What is the difference between the highest and the second highest CO2 emissions (% of total fuel combustion) of Morocco?
Provide a short and direct response. 0.08. What is the difference between the highest and the second highest CO2 emissions (% of total fuel combustion) in Mozambique?
Offer a very short reply. 0.56. What is the difference between the highest and the lowest CO2 emissions (% of total fuel combustion) in Middle income?
Make the answer very short. 2. What is the difference between the highest and the lowest CO2 emissions (% of total fuel combustion) of Albania?
Your answer should be compact. 23.54. What is the difference between the highest and the lowest CO2 emissions (% of total fuel combustion) of Morocco?
Your answer should be very brief. 1.61. What is the difference between the highest and the lowest CO2 emissions (% of total fuel combustion) of Mozambique?
Give a very brief answer. 4.54. 